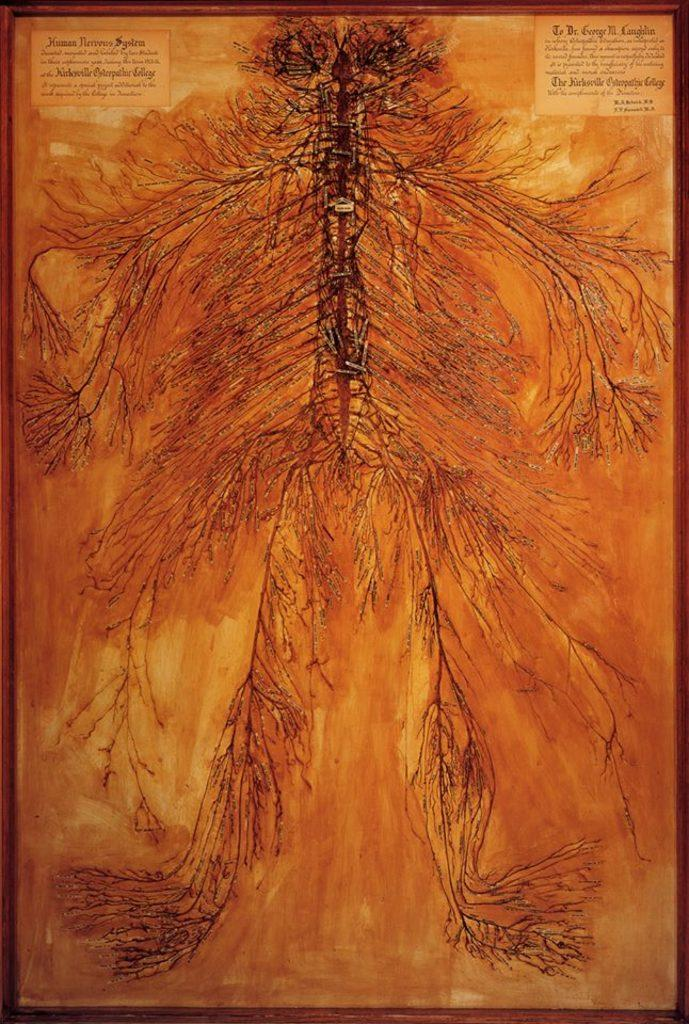What is the main subject of the drawing in the image? The drawing is of the human nervous system. What is the color of the drawing? The drawing is in a brown color. How is the drawing displayed in the image? The drawing is in a picture frame. Can you see any hoses or quicksand in the image? No, there are no hoses or quicksand present in the image. How many flocks of birds are visible in the image? There are no flocks of birds visible in the image, as it features a drawing of the human nervous system in a picture frame. 